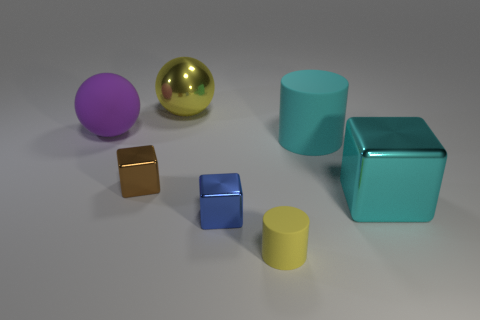Subtract all tiny cubes. How many cubes are left? 1 Add 1 purple matte spheres. How many objects exist? 8 Subtract all blocks. How many objects are left? 4 Subtract 1 brown blocks. How many objects are left? 6 Subtract all blue cubes. Subtract all gray balls. How many cubes are left? 2 Subtract all tiny yellow rubber balls. Subtract all brown things. How many objects are left? 6 Add 1 large purple balls. How many large purple balls are left? 2 Add 1 tiny rubber things. How many tiny rubber things exist? 2 